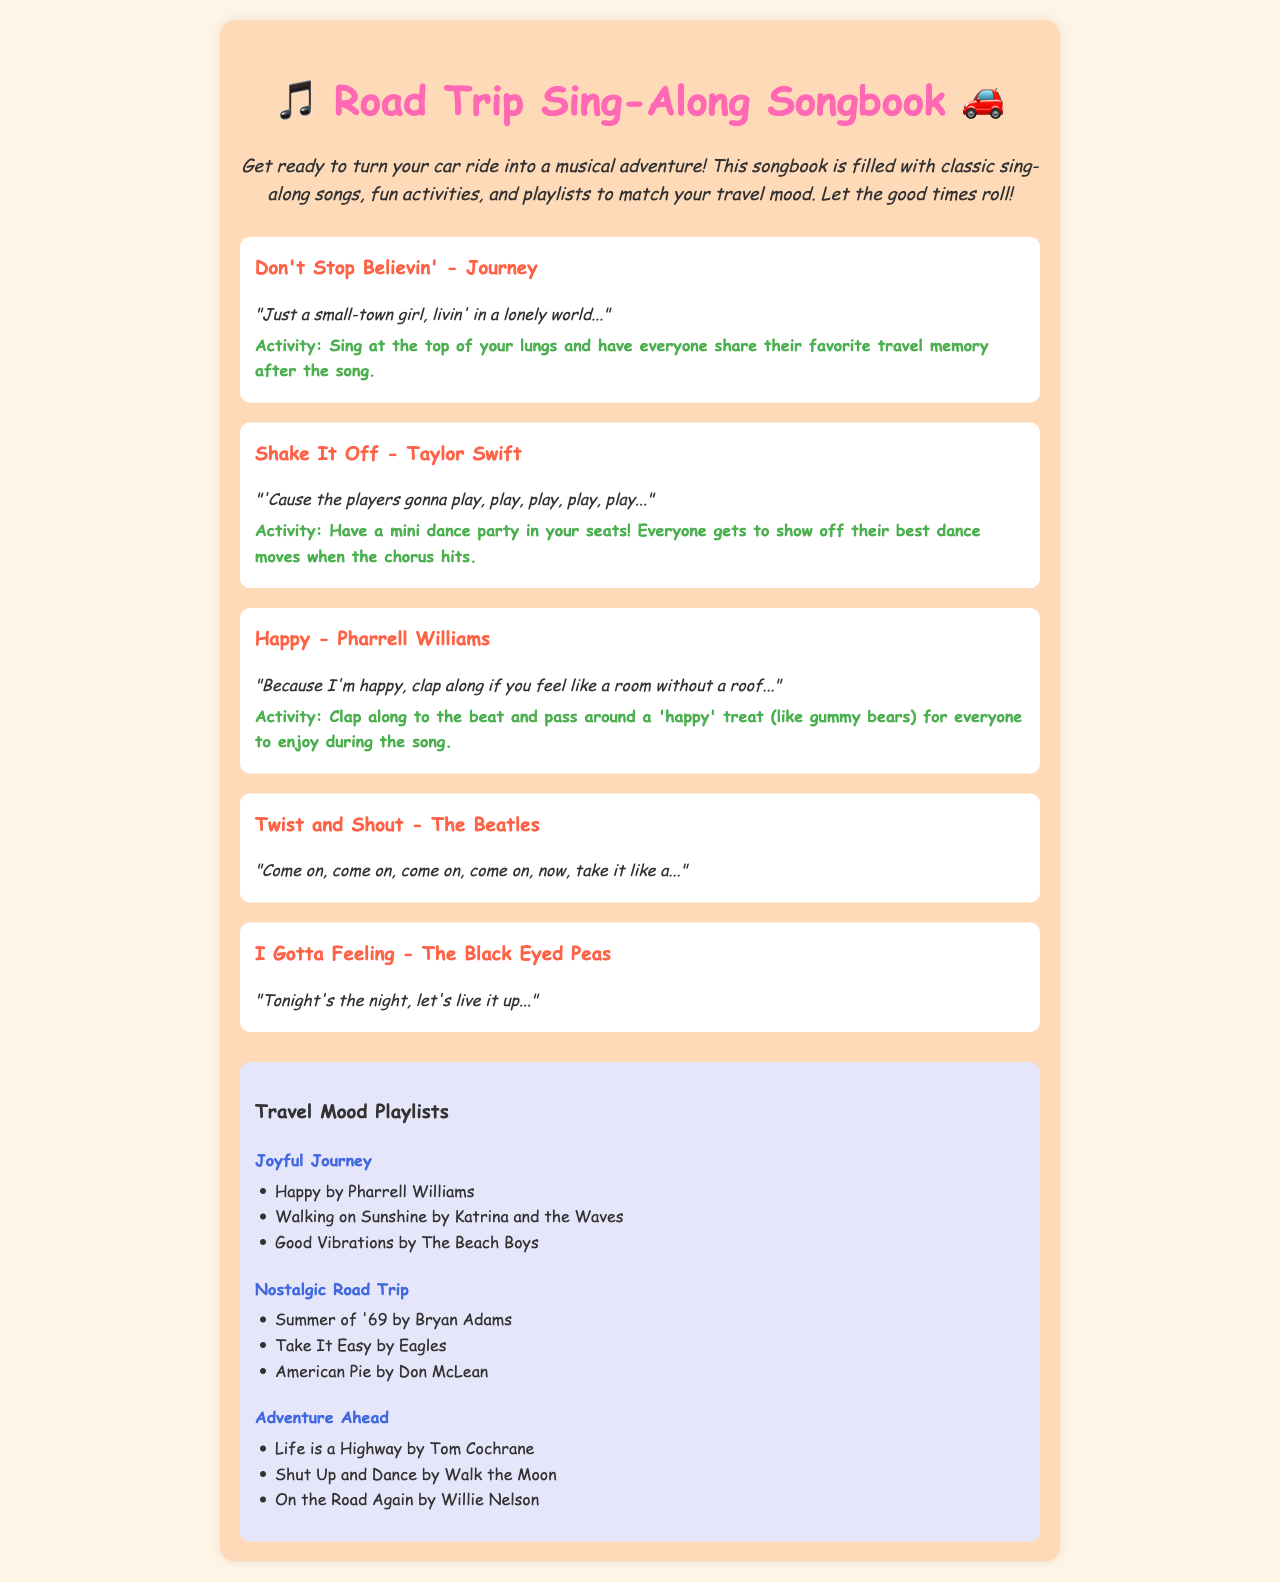What is the title of the song by Journey? The title is clearly mentioned in the song section of the document, which is "Don't Stop Believin'."
Answer: Don't Stop Believin' What activity is suggested for "Shake It Off"? The document provides an activity suggestion alongside the song, which is "Have a mini dance party in your seats!"
Answer: Have a mini dance party in your seats! How many songs are listed in the document? By counting the song sections, there are a total of five songs included.
Answer: Five Which song features lyrics about being "happy"? This song is explicitly mentioned in the lyrics section as featuring the word "happy."
Answer: Happy What mood is associated with the playlist titled "Joyful Journey"? The title itself suggests a positive and cheerful atmosphere related to travel.
Answer: Joyful Journey Which singer performs "I Gotta Feeling"? The document lists the song and its performer, which is The Black Eyed Peas.
Answer: The Black Eyed Peas What is the theme of the "Nostalgic Road Trip" playlist? The songs in this playlist reflect a sense of nostalgia and fond memories of past times.
Answer: Nostalgic Road Trip How many songs are listed under the "Adventure Ahead" playlist? The document indicates that there are three songs in this particular playlist.
Answer: Three What color is used for the song titles? The song titles are displayed in a specific color as indicated in the document styling, which is #FF6347.
Answer: #FF6347 